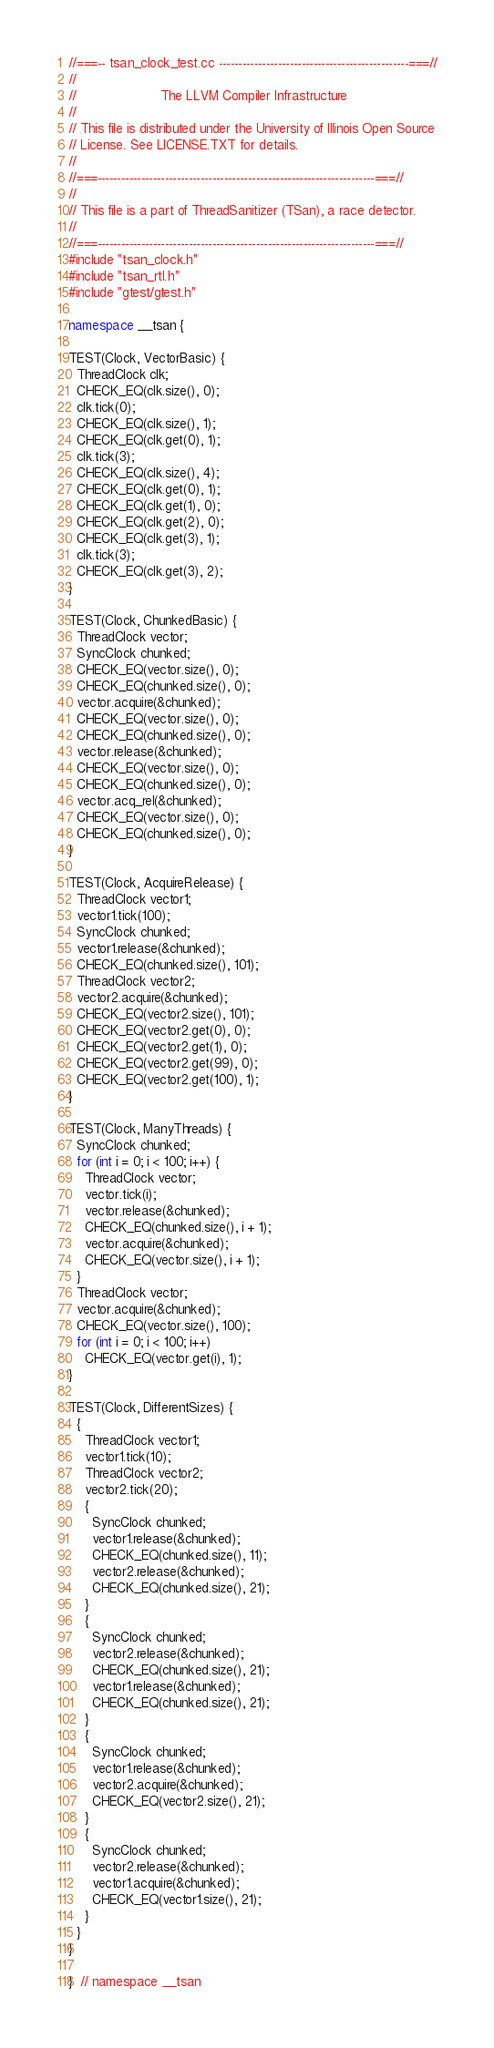Convert code to text. <code><loc_0><loc_0><loc_500><loc_500><_C++_>//===-- tsan_clock_test.cc ------------------------------------------------===//
//
//                     The LLVM Compiler Infrastructure
//
// This file is distributed under the University of Illinois Open Source
// License. See LICENSE.TXT for details.
//
//===----------------------------------------------------------------------===//
//
// This file is a part of ThreadSanitizer (TSan), a race detector.
//
//===----------------------------------------------------------------------===//
#include "tsan_clock.h"
#include "tsan_rtl.h"
#include "gtest/gtest.h"

namespace __tsan {

TEST(Clock, VectorBasic) {
  ThreadClock clk;
  CHECK_EQ(clk.size(), 0);
  clk.tick(0);
  CHECK_EQ(clk.size(), 1);
  CHECK_EQ(clk.get(0), 1);
  clk.tick(3);
  CHECK_EQ(clk.size(), 4);
  CHECK_EQ(clk.get(0), 1);
  CHECK_EQ(clk.get(1), 0);
  CHECK_EQ(clk.get(2), 0);
  CHECK_EQ(clk.get(3), 1);
  clk.tick(3);
  CHECK_EQ(clk.get(3), 2);
}

TEST(Clock, ChunkedBasic) {
  ThreadClock vector;
  SyncClock chunked;
  CHECK_EQ(vector.size(), 0);
  CHECK_EQ(chunked.size(), 0);
  vector.acquire(&chunked);
  CHECK_EQ(vector.size(), 0);
  CHECK_EQ(chunked.size(), 0);
  vector.release(&chunked);
  CHECK_EQ(vector.size(), 0);
  CHECK_EQ(chunked.size(), 0);
  vector.acq_rel(&chunked);
  CHECK_EQ(vector.size(), 0);
  CHECK_EQ(chunked.size(), 0);
}

TEST(Clock, AcquireRelease) {
  ThreadClock vector1;
  vector1.tick(100);
  SyncClock chunked;
  vector1.release(&chunked);
  CHECK_EQ(chunked.size(), 101);
  ThreadClock vector2;
  vector2.acquire(&chunked);
  CHECK_EQ(vector2.size(), 101);
  CHECK_EQ(vector2.get(0), 0);
  CHECK_EQ(vector2.get(1), 0);
  CHECK_EQ(vector2.get(99), 0);
  CHECK_EQ(vector2.get(100), 1);
}

TEST(Clock, ManyThreads) {
  SyncClock chunked;
  for (int i = 0; i < 100; i++) {
    ThreadClock vector;
    vector.tick(i);
    vector.release(&chunked);
    CHECK_EQ(chunked.size(), i + 1);
    vector.acquire(&chunked);
    CHECK_EQ(vector.size(), i + 1);
  }
  ThreadClock vector;
  vector.acquire(&chunked);
  CHECK_EQ(vector.size(), 100);
  for (int i = 0; i < 100; i++)
    CHECK_EQ(vector.get(i), 1);
}

TEST(Clock, DifferentSizes) {
  {
    ThreadClock vector1;
    vector1.tick(10);
    ThreadClock vector2;
    vector2.tick(20);
    {
      SyncClock chunked;
      vector1.release(&chunked);
      CHECK_EQ(chunked.size(), 11);
      vector2.release(&chunked);
      CHECK_EQ(chunked.size(), 21);
    }
    {
      SyncClock chunked;
      vector2.release(&chunked);
      CHECK_EQ(chunked.size(), 21);
      vector1.release(&chunked);
      CHECK_EQ(chunked.size(), 21);
    }
    {
      SyncClock chunked;
      vector1.release(&chunked);
      vector2.acquire(&chunked);
      CHECK_EQ(vector2.size(), 21);
    }
    {
      SyncClock chunked;
      vector2.release(&chunked);
      vector1.acquire(&chunked);
      CHECK_EQ(vector1.size(), 21);
    }
  }
}

}  // namespace __tsan
</code> 